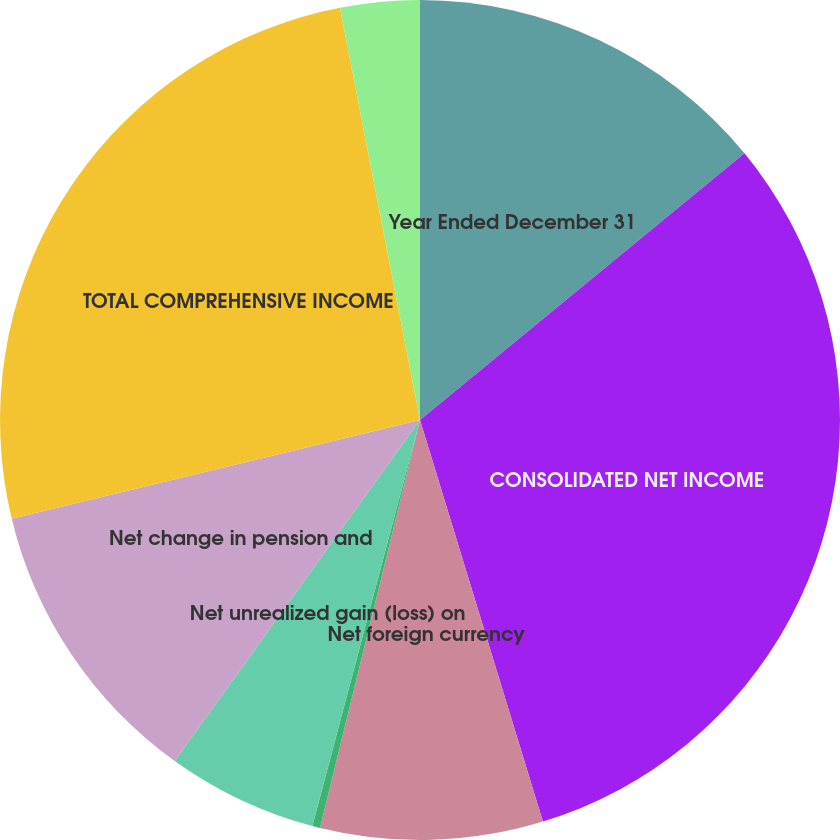Convert chart. <chart><loc_0><loc_0><loc_500><loc_500><pie_chart><fcel>Year Ended December 31<fcel>CONSOLIDATED NET INCOME<fcel>Net foreign currency<fcel>Net gain (loss) on derivatives<fcel>Net unrealized gain (loss) on<fcel>Net change in pension and<fcel>TOTAL COMPREHENSIVE INCOME<fcel>Less Comprehensive income<nl><fcel>14.05%<fcel>31.22%<fcel>8.55%<fcel>0.3%<fcel>5.8%<fcel>11.3%<fcel>25.72%<fcel>3.05%<nl></chart> 